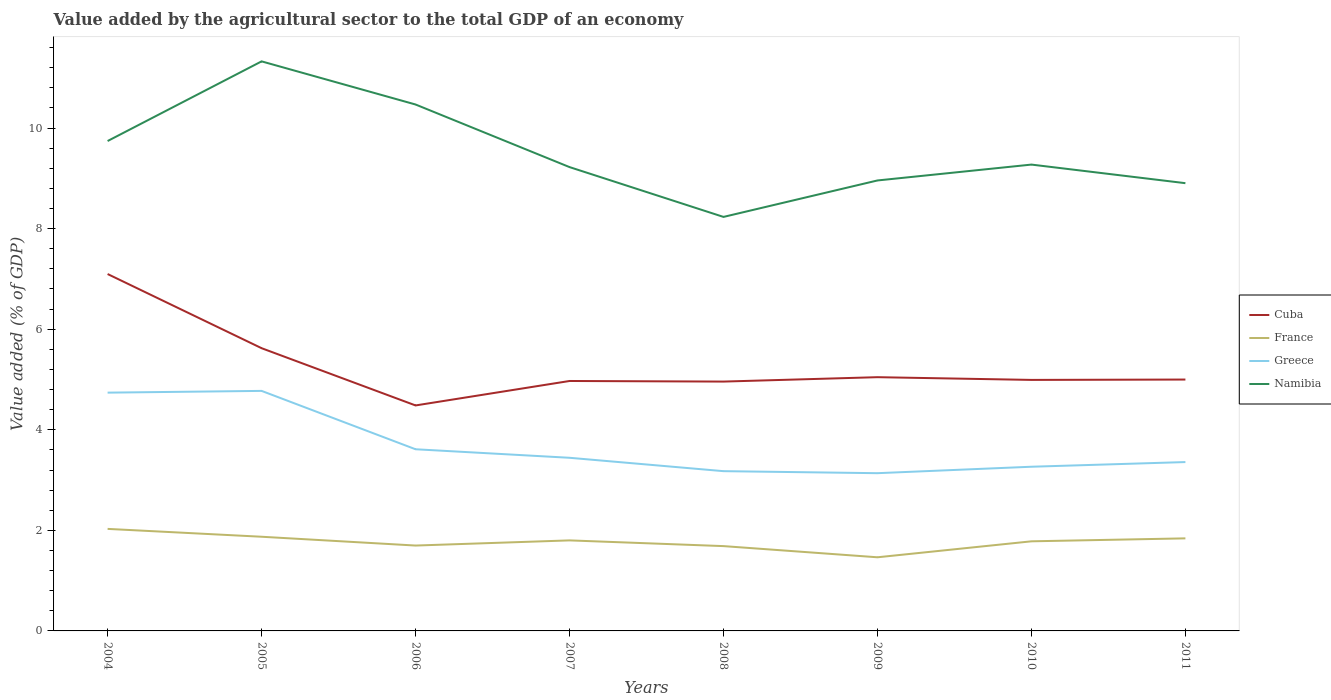How many different coloured lines are there?
Ensure brevity in your answer.  4. Does the line corresponding to France intersect with the line corresponding to Greece?
Your answer should be very brief. No. Across all years, what is the maximum value added by the agricultural sector to the total GDP in Cuba?
Ensure brevity in your answer.  4.48. In which year was the value added by the agricultural sector to the total GDP in Greece maximum?
Offer a terse response. 2009. What is the total value added by the agricultural sector to the total GDP in Greece in the graph?
Your answer should be very brief. 0.25. What is the difference between the highest and the second highest value added by the agricultural sector to the total GDP in Cuba?
Ensure brevity in your answer.  2.61. What is the difference between two consecutive major ticks on the Y-axis?
Provide a short and direct response. 2. Where does the legend appear in the graph?
Your answer should be compact. Center right. What is the title of the graph?
Offer a terse response. Value added by the agricultural sector to the total GDP of an economy. What is the label or title of the X-axis?
Make the answer very short. Years. What is the label or title of the Y-axis?
Ensure brevity in your answer.  Value added (% of GDP). What is the Value added (% of GDP) in Cuba in 2004?
Offer a terse response. 7.1. What is the Value added (% of GDP) in France in 2004?
Keep it short and to the point. 2.03. What is the Value added (% of GDP) in Greece in 2004?
Provide a short and direct response. 4.74. What is the Value added (% of GDP) in Namibia in 2004?
Offer a terse response. 9.74. What is the Value added (% of GDP) of Cuba in 2005?
Give a very brief answer. 5.62. What is the Value added (% of GDP) in France in 2005?
Your answer should be very brief. 1.87. What is the Value added (% of GDP) of Greece in 2005?
Offer a terse response. 4.77. What is the Value added (% of GDP) in Namibia in 2005?
Give a very brief answer. 11.33. What is the Value added (% of GDP) of Cuba in 2006?
Keep it short and to the point. 4.48. What is the Value added (% of GDP) in France in 2006?
Make the answer very short. 1.7. What is the Value added (% of GDP) in Greece in 2006?
Provide a succinct answer. 3.61. What is the Value added (% of GDP) in Namibia in 2006?
Offer a terse response. 10.47. What is the Value added (% of GDP) of Cuba in 2007?
Provide a short and direct response. 4.97. What is the Value added (% of GDP) of France in 2007?
Give a very brief answer. 1.8. What is the Value added (% of GDP) in Greece in 2007?
Your answer should be compact. 3.44. What is the Value added (% of GDP) in Namibia in 2007?
Provide a short and direct response. 9.22. What is the Value added (% of GDP) in Cuba in 2008?
Your answer should be compact. 4.96. What is the Value added (% of GDP) of France in 2008?
Provide a short and direct response. 1.69. What is the Value added (% of GDP) of Greece in 2008?
Your answer should be compact. 3.18. What is the Value added (% of GDP) in Namibia in 2008?
Provide a succinct answer. 8.23. What is the Value added (% of GDP) of Cuba in 2009?
Provide a short and direct response. 5.05. What is the Value added (% of GDP) in France in 2009?
Your response must be concise. 1.46. What is the Value added (% of GDP) of Greece in 2009?
Keep it short and to the point. 3.14. What is the Value added (% of GDP) in Namibia in 2009?
Make the answer very short. 8.96. What is the Value added (% of GDP) of Cuba in 2010?
Your answer should be very brief. 4.99. What is the Value added (% of GDP) in France in 2010?
Make the answer very short. 1.78. What is the Value added (% of GDP) in Greece in 2010?
Your answer should be very brief. 3.27. What is the Value added (% of GDP) in Namibia in 2010?
Keep it short and to the point. 9.27. What is the Value added (% of GDP) in Cuba in 2011?
Offer a terse response. 5. What is the Value added (% of GDP) of France in 2011?
Provide a short and direct response. 1.84. What is the Value added (% of GDP) in Greece in 2011?
Your response must be concise. 3.36. What is the Value added (% of GDP) in Namibia in 2011?
Offer a very short reply. 8.9. Across all years, what is the maximum Value added (% of GDP) of Cuba?
Provide a succinct answer. 7.1. Across all years, what is the maximum Value added (% of GDP) in France?
Ensure brevity in your answer.  2.03. Across all years, what is the maximum Value added (% of GDP) of Greece?
Offer a very short reply. 4.77. Across all years, what is the maximum Value added (% of GDP) in Namibia?
Provide a succinct answer. 11.33. Across all years, what is the minimum Value added (% of GDP) in Cuba?
Make the answer very short. 4.48. Across all years, what is the minimum Value added (% of GDP) in France?
Your answer should be very brief. 1.46. Across all years, what is the minimum Value added (% of GDP) of Greece?
Keep it short and to the point. 3.14. Across all years, what is the minimum Value added (% of GDP) of Namibia?
Keep it short and to the point. 8.23. What is the total Value added (% of GDP) of Cuba in the graph?
Offer a terse response. 42.17. What is the total Value added (% of GDP) of France in the graph?
Provide a short and direct response. 14.17. What is the total Value added (% of GDP) of Greece in the graph?
Your response must be concise. 29.51. What is the total Value added (% of GDP) in Namibia in the graph?
Your answer should be very brief. 76.13. What is the difference between the Value added (% of GDP) of Cuba in 2004 and that in 2005?
Offer a terse response. 1.47. What is the difference between the Value added (% of GDP) in France in 2004 and that in 2005?
Offer a very short reply. 0.16. What is the difference between the Value added (% of GDP) in Greece in 2004 and that in 2005?
Provide a succinct answer. -0.03. What is the difference between the Value added (% of GDP) of Namibia in 2004 and that in 2005?
Your answer should be very brief. -1.58. What is the difference between the Value added (% of GDP) in Cuba in 2004 and that in 2006?
Ensure brevity in your answer.  2.61. What is the difference between the Value added (% of GDP) in France in 2004 and that in 2006?
Your answer should be very brief. 0.33. What is the difference between the Value added (% of GDP) of Greece in 2004 and that in 2006?
Keep it short and to the point. 1.13. What is the difference between the Value added (% of GDP) in Namibia in 2004 and that in 2006?
Provide a short and direct response. -0.73. What is the difference between the Value added (% of GDP) in Cuba in 2004 and that in 2007?
Your response must be concise. 2.13. What is the difference between the Value added (% of GDP) in France in 2004 and that in 2007?
Provide a short and direct response. 0.23. What is the difference between the Value added (% of GDP) of Greece in 2004 and that in 2007?
Ensure brevity in your answer.  1.3. What is the difference between the Value added (% of GDP) of Namibia in 2004 and that in 2007?
Offer a terse response. 0.52. What is the difference between the Value added (% of GDP) in Cuba in 2004 and that in 2008?
Make the answer very short. 2.14. What is the difference between the Value added (% of GDP) in France in 2004 and that in 2008?
Ensure brevity in your answer.  0.34. What is the difference between the Value added (% of GDP) of Greece in 2004 and that in 2008?
Offer a very short reply. 1.56. What is the difference between the Value added (% of GDP) in Namibia in 2004 and that in 2008?
Keep it short and to the point. 1.51. What is the difference between the Value added (% of GDP) in Cuba in 2004 and that in 2009?
Offer a terse response. 2.05. What is the difference between the Value added (% of GDP) of France in 2004 and that in 2009?
Ensure brevity in your answer.  0.56. What is the difference between the Value added (% of GDP) in Greece in 2004 and that in 2009?
Your response must be concise. 1.6. What is the difference between the Value added (% of GDP) in Namibia in 2004 and that in 2009?
Provide a short and direct response. 0.78. What is the difference between the Value added (% of GDP) in Cuba in 2004 and that in 2010?
Provide a short and direct response. 2.11. What is the difference between the Value added (% of GDP) of France in 2004 and that in 2010?
Offer a very short reply. 0.25. What is the difference between the Value added (% of GDP) in Greece in 2004 and that in 2010?
Your answer should be compact. 1.47. What is the difference between the Value added (% of GDP) of Namibia in 2004 and that in 2010?
Your answer should be compact. 0.47. What is the difference between the Value added (% of GDP) in Cuba in 2004 and that in 2011?
Offer a very short reply. 2.1. What is the difference between the Value added (% of GDP) in France in 2004 and that in 2011?
Offer a terse response. 0.19. What is the difference between the Value added (% of GDP) of Greece in 2004 and that in 2011?
Your answer should be very brief. 1.38. What is the difference between the Value added (% of GDP) in Namibia in 2004 and that in 2011?
Give a very brief answer. 0.84. What is the difference between the Value added (% of GDP) in Cuba in 2005 and that in 2006?
Your response must be concise. 1.14. What is the difference between the Value added (% of GDP) of France in 2005 and that in 2006?
Keep it short and to the point. 0.17. What is the difference between the Value added (% of GDP) of Greece in 2005 and that in 2006?
Provide a short and direct response. 1.16. What is the difference between the Value added (% of GDP) of Namibia in 2005 and that in 2006?
Offer a terse response. 0.86. What is the difference between the Value added (% of GDP) in Cuba in 2005 and that in 2007?
Provide a succinct answer. 0.65. What is the difference between the Value added (% of GDP) in France in 2005 and that in 2007?
Your answer should be compact. 0.07. What is the difference between the Value added (% of GDP) in Greece in 2005 and that in 2007?
Ensure brevity in your answer.  1.33. What is the difference between the Value added (% of GDP) in Namibia in 2005 and that in 2007?
Ensure brevity in your answer.  2.1. What is the difference between the Value added (% of GDP) in Cuba in 2005 and that in 2008?
Make the answer very short. 0.66. What is the difference between the Value added (% of GDP) of France in 2005 and that in 2008?
Offer a terse response. 0.19. What is the difference between the Value added (% of GDP) of Greece in 2005 and that in 2008?
Ensure brevity in your answer.  1.6. What is the difference between the Value added (% of GDP) of Namibia in 2005 and that in 2008?
Provide a short and direct response. 3.09. What is the difference between the Value added (% of GDP) in Cuba in 2005 and that in 2009?
Provide a succinct answer. 0.58. What is the difference between the Value added (% of GDP) in France in 2005 and that in 2009?
Keep it short and to the point. 0.41. What is the difference between the Value added (% of GDP) of Greece in 2005 and that in 2009?
Your answer should be compact. 1.64. What is the difference between the Value added (% of GDP) in Namibia in 2005 and that in 2009?
Your answer should be compact. 2.37. What is the difference between the Value added (% of GDP) in Cuba in 2005 and that in 2010?
Provide a succinct answer. 0.63. What is the difference between the Value added (% of GDP) of France in 2005 and that in 2010?
Offer a terse response. 0.09. What is the difference between the Value added (% of GDP) of Greece in 2005 and that in 2010?
Provide a short and direct response. 1.51. What is the difference between the Value added (% of GDP) of Namibia in 2005 and that in 2010?
Keep it short and to the point. 2.05. What is the difference between the Value added (% of GDP) of Cuba in 2005 and that in 2011?
Offer a terse response. 0.62. What is the difference between the Value added (% of GDP) in France in 2005 and that in 2011?
Offer a terse response. 0.03. What is the difference between the Value added (% of GDP) in Greece in 2005 and that in 2011?
Make the answer very short. 1.42. What is the difference between the Value added (% of GDP) of Namibia in 2005 and that in 2011?
Offer a very short reply. 2.42. What is the difference between the Value added (% of GDP) of Cuba in 2006 and that in 2007?
Your answer should be compact. -0.49. What is the difference between the Value added (% of GDP) in France in 2006 and that in 2007?
Your answer should be compact. -0.1. What is the difference between the Value added (% of GDP) of Greece in 2006 and that in 2007?
Offer a very short reply. 0.17. What is the difference between the Value added (% of GDP) of Namibia in 2006 and that in 2007?
Provide a succinct answer. 1.24. What is the difference between the Value added (% of GDP) of Cuba in 2006 and that in 2008?
Provide a short and direct response. -0.47. What is the difference between the Value added (% of GDP) in France in 2006 and that in 2008?
Make the answer very short. 0.01. What is the difference between the Value added (% of GDP) of Greece in 2006 and that in 2008?
Keep it short and to the point. 0.44. What is the difference between the Value added (% of GDP) in Namibia in 2006 and that in 2008?
Offer a terse response. 2.24. What is the difference between the Value added (% of GDP) in Cuba in 2006 and that in 2009?
Keep it short and to the point. -0.56. What is the difference between the Value added (% of GDP) of France in 2006 and that in 2009?
Provide a short and direct response. 0.23. What is the difference between the Value added (% of GDP) of Greece in 2006 and that in 2009?
Offer a very short reply. 0.48. What is the difference between the Value added (% of GDP) in Namibia in 2006 and that in 2009?
Give a very brief answer. 1.51. What is the difference between the Value added (% of GDP) of Cuba in 2006 and that in 2010?
Give a very brief answer. -0.51. What is the difference between the Value added (% of GDP) in France in 2006 and that in 2010?
Keep it short and to the point. -0.08. What is the difference between the Value added (% of GDP) of Greece in 2006 and that in 2010?
Offer a very short reply. 0.35. What is the difference between the Value added (% of GDP) of Namibia in 2006 and that in 2010?
Your response must be concise. 1.19. What is the difference between the Value added (% of GDP) of Cuba in 2006 and that in 2011?
Your answer should be very brief. -0.51. What is the difference between the Value added (% of GDP) in France in 2006 and that in 2011?
Make the answer very short. -0.14. What is the difference between the Value added (% of GDP) of Greece in 2006 and that in 2011?
Provide a short and direct response. 0.25. What is the difference between the Value added (% of GDP) of Namibia in 2006 and that in 2011?
Give a very brief answer. 1.56. What is the difference between the Value added (% of GDP) in Cuba in 2007 and that in 2008?
Ensure brevity in your answer.  0.01. What is the difference between the Value added (% of GDP) of France in 2007 and that in 2008?
Make the answer very short. 0.11. What is the difference between the Value added (% of GDP) in Greece in 2007 and that in 2008?
Your response must be concise. 0.27. What is the difference between the Value added (% of GDP) of Cuba in 2007 and that in 2009?
Provide a succinct answer. -0.08. What is the difference between the Value added (% of GDP) in France in 2007 and that in 2009?
Your response must be concise. 0.34. What is the difference between the Value added (% of GDP) in Greece in 2007 and that in 2009?
Provide a succinct answer. 0.31. What is the difference between the Value added (% of GDP) in Namibia in 2007 and that in 2009?
Ensure brevity in your answer.  0.27. What is the difference between the Value added (% of GDP) in Cuba in 2007 and that in 2010?
Keep it short and to the point. -0.02. What is the difference between the Value added (% of GDP) in France in 2007 and that in 2010?
Offer a terse response. 0.02. What is the difference between the Value added (% of GDP) in Greece in 2007 and that in 2010?
Provide a succinct answer. 0.18. What is the difference between the Value added (% of GDP) of Namibia in 2007 and that in 2010?
Provide a succinct answer. -0.05. What is the difference between the Value added (% of GDP) of Cuba in 2007 and that in 2011?
Your answer should be very brief. -0.03. What is the difference between the Value added (% of GDP) in France in 2007 and that in 2011?
Ensure brevity in your answer.  -0.04. What is the difference between the Value added (% of GDP) in Greece in 2007 and that in 2011?
Your response must be concise. 0.09. What is the difference between the Value added (% of GDP) in Namibia in 2007 and that in 2011?
Provide a succinct answer. 0.32. What is the difference between the Value added (% of GDP) of Cuba in 2008 and that in 2009?
Your answer should be compact. -0.09. What is the difference between the Value added (% of GDP) in France in 2008 and that in 2009?
Provide a short and direct response. 0.22. What is the difference between the Value added (% of GDP) in Greece in 2008 and that in 2009?
Your answer should be compact. 0.04. What is the difference between the Value added (% of GDP) in Namibia in 2008 and that in 2009?
Offer a terse response. -0.72. What is the difference between the Value added (% of GDP) of Cuba in 2008 and that in 2010?
Give a very brief answer. -0.03. What is the difference between the Value added (% of GDP) in France in 2008 and that in 2010?
Your response must be concise. -0.1. What is the difference between the Value added (% of GDP) of Greece in 2008 and that in 2010?
Your answer should be compact. -0.09. What is the difference between the Value added (% of GDP) in Namibia in 2008 and that in 2010?
Your answer should be compact. -1.04. What is the difference between the Value added (% of GDP) of Cuba in 2008 and that in 2011?
Make the answer very short. -0.04. What is the difference between the Value added (% of GDP) of France in 2008 and that in 2011?
Your answer should be compact. -0.15. What is the difference between the Value added (% of GDP) in Greece in 2008 and that in 2011?
Your answer should be compact. -0.18. What is the difference between the Value added (% of GDP) of Namibia in 2008 and that in 2011?
Provide a succinct answer. -0.67. What is the difference between the Value added (% of GDP) in Cuba in 2009 and that in 2010?
Your answer should be compact. 0.05. What is the difference between the Value added (% of GDP) of France in 2009 and that in 2010?
Your answer should be compact. -0.32. What is the difference between the Value added (% of GDP) in Greece in 2009 and that in 2010?
Provide a succinct answer. -0.13. What is the difference between the Value added (% of GDP) in Namibia in 2009 and that in 2010?
Make the answer very short. -0.32. What is the difference between the Value added (% of GDP) of Cuba in 2009 and that in 2011?
Provide a short and direct response. 0.05. What is the difference between the Value added (% of GDP) of France in 2009 and that in 2011?
Make the answer very short. -0.38. What is the difference between the Value added (% of GDP) in Greece in 2009 and that in 2011?
Provide a short and direct response. -0.22. What is the difference between the Value added (% of GDP) in Namibia in 2009 and that in 2011?
Offer a terse response. 0.05. What is the difference between the Value added (% of GDP) in Cuba in 2010 and that in 2011?
Your answer should be compact. -0.01. What is the difference between the Value added (% of GDP) in France in 2010 and that in 2011?
Make the answer very short. -0.06. What is the difference between the Value added (% of GDP) in Greece in 2010 and that in 2011?
Your answer should be very brief. -0.09. What is the difference between the Value added (% of GDP) of Namibia in 2010 and that in 2011?
Offer a very short reply. 0.37. What is the difference between the Value added (% of GDP) in Cuba in 2004 and the Value added (% of GDP) in France in 2005?
Keep it short and to the point. 5.22. What is the difference between the Value added (% of GDP) of Cuba in 2004 and the Value added (% of GDP) of Greece in 2005?
Provide a short and direct response. 2.32. What is the difference between the Value added (% of GDP) in Cuba in 2004 and the Value added (% of GDP) in Namibia in 2005?
Ensure brevity in your answer.  -4.23. What is the difference between the Value added (% of GDP) of France in 2004 and the Value added (% of GDP) of Greece in 2005?
Offer a terse response. -2.74. What is the difference between the Value added (% of GDP) in France in 2004 and the Value added (% of GDP) in Namibia in 2005?
Provide a succinct answer. -9.3. What is the difference between the Value added (% of GDP) in Greece in 2004 and the Value added (% of GDP) in Namibia in 2005?
Your response must be concise. -6.59. What is the difference between the Value added (% of GDP) of Cuba in 2004 and the Value added (% of GDP) of France in 2006?
Offer a very short reply. 5.4. What is the difference between the Value added (% of GDP) in Cuba in 2004 and the Value added (% of GDP) in Greece in 2006?
Give a very brief answer. 3.48. What is the difference between the Value added (% of GDP) in Cuba in 2004 and the Value added (% of GDP) in Namibia in 2006?
Make the answer very short. -3.37. What is the difference between the Value added (% of GDP) of France in 2004 and the Value added (% of GDP) of Greece in 2006?
Offer a very short reply. -1.58. What is the difference between the Value added (% of GDP) of France in 2004 and the Value added (% of GDP) of Namibia in 2006?
Your answer should be compact. -8.44. What is the difference between the Value added (% of GDP) of Greece in 2004 and the Value added (% of GDP) of Namibia in 2006?
Your response must be concise. -5.73. What is the difference between the Value added (% of GDP) in Cuba in 2004 and the Value added (% of GDP) in France in 2007?
Your answer should be very brief. 5.3. What is the difference between the Value added (% of GDP) in Cuba in 2004 and the Value added (% of GDP) in Greece in 2007?
Your response must be concise. 3.65. What is the difference between the Value added (% of GDP) of Cuba in 2004 and the Value added (% of GDP) of Namibia in 2007?
Provide a succinct answer. -2.13. What is the difference between the Value added (% of GDP) in France in 2004 and the Value added (% of GDP) in Greece in 2007?
Keep it short and to the point. -1.41. What is the difference between the Value added (% of GDP) of France in 2004 and the Value added (% of GDP) of Namibia in 2007?
Provide a short and direct response. -7.2. What is the difference between the Value added (% of GDP) of Greece in 2004 and the Value added (% of GDP) of Namibia in 2007?
Keep it short and to the point. -4.49. What is the difference between the Value added (% of GDP) in Cuba in 2004 and the Value added (% of GDP) in France in 2008?
Offer a terse response. 5.41. What is the difference between the Value added (% of GDP) in Cuba in 2004 and the Value added (% of GDP) in Greece in 2008?
Provide a short and direct response. 3.92. What is the difference between the Value added (% of GDP) in Cuba in 2004 and the Value added (% of GDP) in Namibia in 2008?
Your answer should be compact. -1.14. What is the difference between the Value added (% of GDP) of France in 2004 and the Value added (% of GDP) of Greece in 2008?
Offer a terse response. -1.15. What is the difference between the Value added (% of GDP) of France in 2004 and the Value added (% of GDP) of Namibia in 2008?
Ensure brevity in your answer.  -6.2. What is the difference between the Value added (% of GDP) of Greece in 2004 and the Value added (% of GDP) of Namibia in 2008?
Your answer should be very brief. -3.49. What is the difference between the Value added (% of GDP) in Cuba in 2004 and the Value added (% of GDP) in France in 2009?
Make the answer very short. 5.63. What is the difference between the Value added (% of GDP) in Cuba in 2004 and the Value added (% of GDP) in Greece in 2009?
Ensure brevity in your answer.  3.96. What is the difference between the Value added (% of GDP) of Cuba in 2004 and the Value added (% of GDP) of Namibia in 2009?
Provide a short and direct response. -1.86. What is the difference between the Value added (% of GDP) in France in 2004 and the Value added (% of GDP) in Greece in 2009?
Give a very brief answer. -1.11. What is the difference between the Value added (% of GDP) in France in 2004 and the Value added (% of GDP) in Namibia in 2009?
Provide a short and direct response. -6.93. What is the difference between the Value added (% of GDP) in Greece in 2004 and the Value added (% of GDP) in Namibia in 2009?
Provide a succinct answer. -4.22. What is the difference between the Value added (% of GDP) in Cuba in 2004 and the Value added (% of GDP) in France in 2010?
Your answer should be compact. 5.32. What is the difference between the Value added (% of GDP) of Cuba in 2004 and the Value added (% of GDP) of Greece in 2010?
Keep it short and to the point. 3.83. What is the difference between the Value added (% of GDP) in Cuba in 2004 and the Value added (% of GDP) in Namibia in 2010?
Provide a succinct answer. -2.18. What is the difference between the Value added (% of GDP) of France in 2004 and the Value added (% of GDP) of Greece in 2010?
Provide a succinct answer. -1.24. What is the difference between the Value added (% of GDP) in France in 2004 and the Value added (% of GDP) in Namibia in 2010?
Your response must be concise. -7.25. What is the difference between the Value added (% of GDP) of Greece in 2004 and the Value added (% of GDP) of Namibia in 2010?
Provide a short and direct response. -4.54. What is the difference between the Value added (% of GDP) of Cuba in 2004 and the Value added (% of GDP) of France in 2011?
Keep it short and to the point. 5.26. What is the difference between the Value added (% of GDP) of Cuba in 2004 and the Value added (% of GDP) of Greece in 2011?
Your response must be concise. 3.74. What is the difference between the Value added (% of GDP) in Cuba in 2004 and the Value added (% of GDP) in Namibia in 2011?
Give a very brief answer. -1.81. What is the difference between the Value added (% of GDP) in France in 2004 and the Value added (% of GDP) in Greece in 2011?
Make the answer very short. -1.33. What is the difference between the Value added (% of GDP) in France in 2004 and the Value added (% of GDP) in Namibia in 2011?
Give a very brief answer. -6.88. What is the difference between the Value added (% of GDP) of Greece in 2004 and the Value added (% of GDP) of Namibia in 2011?
Offer a terse response. -4.17. What is the difference between the Value added (% of GDP) in Cuba in 2005 and the Value added (% of GDP) in France in 2006?
Your response must be concise. 3.92. What is the difference between the Value added (% of GDP) in Cuba in 2005 and the Value added (% of GDP) in Greece in 2006?
Make the answer very short. 2.01. What is the difference between the Value added (% of GDP) in Cuba in 2005 and the Value added (% of GDP) in Namibia in 2006?
Provide a short and direct response. -4.85. What is the difference between the Value added (% of GDP) in France in 2005 and the Value added (% of GDP) in Greece in 2006?
Keep it short and to the point. -1.74. What is the difference between the Value added (% of GDP) of France in 2005 and the Value added (% of GDP) of Namibia in 2006?
Provide a short and direct response. -8.6. What is the difference between the Value added (% of GDP) of Greece in 2005 and the Value added (% of GDP) of Namibia in 2006?
Provide a succinct answer. -5.7. What is the difference between the Value added (% of GDP) in Cuba in 2005 and the Value added (% of GDP) in France in 2007?
Offer a very short reply. 3.82. What is the difference between the Value added (% of GDP) of Cuba in 2005 and the Value added (% of GDP) of Greece in 2007?
Your answer should be compact. 2.18. What is the difference between the Value added (% of GDP) in Cuba in 2005 and the Value added (% of GDP) in Namibia in 2007?
Make the answer very short. -3.6. What is the difference between the Value added (% of GDP) of France in 2005 and the Value added (% of GDP) of Greece in 2007?
Provide a short and direct response. -1.57. What is the difference between the Value added (% of GDP) in France in 2005 and the Value added (% of GDP) in Namibia in 2007?
Make the answer very short. -7.35. What is the difference between the Value added (% of GDP) of Greece in 2005 and the Value added (% of GDP) of Namibia in 2007?
Provide a succinct answer. -4.45. What is the difference between the Value added (% of GDP) in Cuba in 2005 and the Value added (% of GDP) in France in 2008?
Offer a very short reply. 3.94. What is the difference between the Value added (% of GDP) in Cuba in 2005 and the Value added (% of GDP) in Greece in 2008?
Your response must be concise. 2.45. What is the difference between the Value added (% of GDP) of Cuba in 2005 and the Value added (% of GDP) of Namibia in 2008?
Ensure brevity in your answer.  -2.61. What is the difference between the Value added (% of GDP) of France in 2005 and the Value added (% of GDP) of Greece in 2008?
Your answer should be very brief. -1.3. What is the difference between the Value added (% of GDP) in France in 2005 and the Value added (% of GDP) in Namibia in 2008?
Ensure brevity in your answer.  -6.36. What is the difference between the Value added (% of GDP) of Greece in 2005 and the Value added (% of GDP) of Namibia in 2008?
Make the answer very short. -3.46. What is the difference between the Value added (% of GDP) of Cuba in 2005 and the Value added (% of GDP) of France in 2009?
Offer a terse response. 4.16. What is the difference between the Value added (% of GDP) in Cuba in 2005 and the Value added (% of GDP) in Greece in 2009?
Your answer should be very brief. 2.49. What is the difference between the Value added (% of GDP) of Cuba in 2005 and the Value added (% of GDP) of Namibia in 2009?
Your answer should be very brief. -3.34. What is the difference between the Value added (% of GDP) in France in 2005 and the Value added (% of GDP) in Greece in 2009?
Offer a very short reply. -1.26. What is the difference between the Value added (% of GDP) of France in 2005 and the Value added (% of GDP) of Namibia in 2009?
Give a very brief answer. -7.09. What is the difference between the Value added (% of GDP) in Greece in 2005 and the Value added (% of GDP) in Namibia in 2009?
Provide a short and direct response. -4.18. What is the difference between the Value added (% of GDP) in Cuba in 2005 and the Value added (% of GDP) in France in 2010?
Offer a very short reply. 3.84. What is the difference between the Value added (% of GDP) of Cuba in 2005 and the Value added (% of GDP) of Greece in 2010?
Your answer should be compact. 2.36. What is the difference between the Value added (% of GDP) in Cuba in 2005 and the Value added (% of GDP) in Namibia in 2010?
Make the answer very short. -3.65. What is the difference between the Value added (% of GDP) of France in 2005 and the Value added (% of GDP) of Greece in 2010?
Offer a very short reply. -1.39. What is the difference between the Value added (% of GDP) in France in 2005 and the Value added (% of GDP) in Namibia in 2010?
Your response must be concise. -7.4. What is the difference between the Value added (% of GDP) of Greece in 2005 and the Value added (% of GDP) of Namibia in 2010?
Give a very brief answer. -4.5. What is the difference between the Value added (% of GDP) of Cuba in 2005 and the Value added (% of GDP) of France in 2011?
Offer a very short reply. 3.78. What is the difference between the Value added (% of GDP) in Cuba in 2005 and the Value added (% of GDP) in Greece in 2011?
Your answer should be very brief. 2.26. What is the difference between the Value added (% of GDP) of Cuba in 2005 and the Value added (% of GDP) of Namibia in 2011?
Make the answer very short. -3.28. What is the difference between the Value added (% of GDP) in France in 2005 and the Value added (% of GDP) in Greece in 2011?
Provide a succinct answer. -1.49. What is the difference between the Value added (% of GDP) of France in 2005 and the Value added (% of GDP) of Namibia in 2011?
Give a very brief answer. -7.03. What is the difference between the Value added (% of GDP) in Greece in 2005 and the Value added (% of GDP) in Namibia in 2011?
Ensure brevity in your answer.  -4.13. What is the difference between the Value added (% of GDP) of Cuba in 2006 and the Value added (% of GDP) of France in 2007?
Keep it short and to the point. 2.68. What is the difference between the Value added (% of GDP) of Cuba in 2006 and the Value added (% of GDP) of Greece in 2007?
Ensure brevity in your answer.  1.04. What is the difference between the Value added (% of GDP) of Cuba in 2006 and the Value added (% of GDP) of Namibia in 2007?
Keep it short and to the point. -4.74. What is the difference between the Value added (% of GDP) of France in 2006 and the Value added (% of GDP) of Greece in 2007?
Offer a very short reply. -1.75. What is the difference between the Value added (% of GDP) of France in 2006 and the Value added (% of GDP) of Namibia in 2007?
Make the answer very short. -7.53. What is the difference between the Value added (% of GDP) of Greece in 2006 and the Value added (% of GDP) of Namibia in 2007?
Provide a succinct answer. -5.61. What is the difference between the Value added (% of GDP) of Cuba in 2006 and the Value added (% of GDP) of France in 2008?
Provide a short and direct response. 2.8. What is the difference between the Value added (% of GDP) in Cuba in 2006 and the Value added (% of GDP) in Greece in 2008?
Offer a very short reply. 1.31. What is the difference between the Value added (% of GDP) of Cuba in 2006 and the Value added (% of GDP) of Namibia in 2008?
Your answer should be very brief. -3.75. What is the difference between the Value added (% of GDP) of France in 2006 and the Value added (% of GDP) of Greece in 2008?
Your answer should be compact. -1.48. What is the difference between the Value added (% of GDP) of France in 2006 and the Value added (% of GDP) of Namibia in 2008?
Keep it short and to the point. -6.54. What is the difference between the Value added (% of GDP) of Greece in 2006 and the Value added (% of GDP) of Namibia in 2008?
Ensure brevity in your answer.  -4.62. What is the difference between the Value added (% of GDP) of Cuba in 2006 and the Value added (% of GDP) of France in 2009?
Ensure brevity in your answer.  3.02. What is the difference between the Value added (% of GDP) of Cuba in 2006 and the Value added (% of GDP) of Greece in 2009?
Your response must be concise. 1.35. What is the difference between the Value added (% of GDP) of Cuba in 2006 and the Value added (% of GDP) of Namibia in 2009?
Provide a short and direct response. -4.47. What is the difference between the Value added (% of GDP) of France in 2006 and the Value added (% of GDP) of Greece in 2009?
Provide a succinct answer. -1.44. What is the difference between the Value added (% of GDP) of France in 2006 and the Value added (% of GDP) of Namibia in 2009?
Offer a very short reply. -7.26. What is the difference between the Value added (% of GDP) in Greece in 2006 and the Value added (% of GDP) in Namibia in 2009?
Offer a terse response. -5.35. What is the difference between the Value added (% of GDP) of Cuba in 2006 and the Value added (% of GDP) of France in 2010?
Give a very brief answer. 2.7. What is the difference between the Value added (% of GDP) of Cuba in 2006 and the Value added (% of GDP) of Greece in 2010?
Offer a terse response. 1.22. What is the difference between the Value added (% of GDP) of Cuba in 2006 and the Value added (% of GDP) of Namibia in 2010?
Offer a terse response. -4.79. What is the difference between the Value added (% of GDP) of France in 2006 and the Value added (% of GDP) of Greece in 2010?
Provide a short and direct response. -1.57. What is the difference between the Value added (% of GDP) of France in 2006 and the Value added (% of GDP) of Namibia in 2010?
Your response must be concise. -7.58. What is the difference between the Value added (% of GDP) in Greece in 2006 and the Value added (% of GDP) in Namibia in 2010?
Offer a terse response. -5.66. What is the difference between the Value added (% of GDP) in Cuba in 2006 and the Value added (% of GDP) in France in 2011?
Provide a short and direct response. 2.64. What is the difference between the Value added (% of GDP) of Cuba in 2006 and the Value added (% of GDP) of Greece in 2011?
Your answer should be compact. 1.13. What is the difference between the Value added (% of GDP) in Cuba in 2006 and the Value added (% of GDP) in Namibia in 2011?
Ensure brevity in your answer.  -4.42. What is the difference between the Value added (% of GDP) of France in 2006 and the Value added (% of GDP) of Greece in 2011?
Your answer should be compact. -1.66. What is the difference between the Value added (% of GDP) of France in 2006 and the Value added (% of GDP) of Namibia in 2011?
Your answer should be compact. -7.21. What is the difference between the Value added (% of GDP) in Greece in 2006 and the Value added (% of GDP) in Namibia in 2011?
Provide a succinct answer. -5.29. What is the difference between the Value added (% of GDP) in Cuba in 2007 and the Value added (% of GDP) in France in 2008?
Your answer should be compact. 3.28. What is the difference between the Value added (% of GDP) of Cuba in 2007 and the Value added (% of GDP) of Greece in 2008?
Ensure brevity in your answer.  1.79. What is the difference between the Value added (% of GDP) of Cuba in 2007 and the Value added (% of GDP) of Namibia in 2008?
Give a very brief answer. -3.26. What is the difference between the Value added (% of GDP) of France in 2007 and the Value added (% of GDP) of Greece in 2008?
Ensure brevity in your answer.  -1.38. What is the difference between the Value added (% of GDP) of France in 2007 and the Value added (% of GDP) of Namibia in 2008?
Ensure brevity in your answer.  -6.43. What is the difference between the Value added (% of GDP) in Greece in 2007 and the Value added (% of GDP) in Namibia in 2008?
Your answer should be compact. -4.79. What is the difference between the Value added (% of GDP) in Cuba in 2007 and the Value added (% of GDP) in France in 2009?
Offer a terse response. 3.51. What is the difference between the Value added (% of GDP) of Cuba in 2007 and the Value added (% of GDP) of Greece in 2009?
Your answer should be compact. 1.83. What is the difference between the Value added (% of GDP) in Cuba in 2007 and the Value added (% of GDP) in Namibia in 2009?
Provide a succinct answer. -3.99. What is the difference between the Value added (% of GDP) in France in 2007 and the Value added (% of GDP) in Greece in 2009?
Keep it short and to the point. -1.34. What is the difference between the Value added (% of GDP) of France in 2007 and the Value added (% of GDP) of Namibia in 2009?
Provide a short and direct response. -7.16. What is the difference between the Value added (% of GDP) in Greece in 2007 and the Value added (% of GDP) in Namibia in 2009?
Offer a very short reply. -5.52. What is the difference between the Value added (% of GDP) in Cuba in 2007 and the Value added (% of GDP) in France in 2010?
Keep it short and to the point. 3.19. What is the difference between the Value added (% of GDP) in Cuba in 2007 and the Value added (% of GDP) in Greece in 2010?
Your answer should be very brief. 1.71. What is the difference between the Value added (% of GDP) in Cuba in 2007 and the Value added (% of GDP) in Namibia in 2010?
Keep it short and to the point. -4.3. What is the difference between the Value added (% of GDP) of France in 2007 and the Value added (% of GDP) of Greece in 2010?
Ensure brevity in your answer.  -1.46. What is the difference between the Value added (% of GDP) of France in 2007 and the Value added (% of GDP) of Namibia in 2010?
Your answer should be compact. -7.47. What is the difference between the Value added (% of GDP) in Greece in 2007 and the Value added (% of GDP) in Namibia in 2010?
Ensure brevity in your answer.  -5.83. What is the difference between the Value added (% of GDP) of Cuba in 2007 and the Value added (% of GDP) of France in 2011?
Make the answer very short. 3.13. What is the difference between the Value added (% of GDP) in Cuba in 2007 and the Value added (% of GDP) in Greece in 2011?
Your answer should be very brief. 1.61. What is the difference between the Value added (% of GDP) of Cuba in 2007 and the Value added (% of GDP) of Namibia in 2011?
Ensure brevity in your answer.  -3.93. What is the difference between the Value added (% of GDP) of France in 2007 and the Value added (% of GDP) of Greece in 2011?
Offer a very short reply. -1.56. What is the difference between the Value added (% of GDP) of France in 2007 and the Value added (% of GDP) of Namibia in 2011?
Your answer should be very brief. -7.1. What is the difference between the Value added (% of GDP) of Greece in 2007 and the Value added (% of GDP) of Namibia in 2011?
Ensure brevity in your answer.  -5.46. What is the difference between the Value added (% of GDP) in Cuba in 2008 and the Value added (% of GDP) in France in 2009?
Provide a succinct answer. 3.49. What is the difference between the Value added (% of GDP) in Cuba in 2008 and the Value added (% of GDP) in Greece in 2009?
Provide a short and direct response. 1.82. What is the difference between the Value added (% of GDP) of Cuba in 2008 and the Value added (% of GDP) of Namibia in 2009?
Provide a short and direct response. -4. What is the difference between the Value added (% of GDP) of France in 2008 and the Value added (% of GDP) of Greece in 2009?
Give a very brief answer. -1.45. What is the difference between the Value added (% of GDP) of France in 2008 and the Value added (% of GDP) of Namibia in 2009?
Give a very brief answer. -7.27. What is the difference between the Value added (% of GDP) in Greece in 2008 and the Value added (% of GDP) in Namibia in 2009?
Offer a very short reply. -5.78. What is the difference between the Value added (% of GDP) of Cuba in 2008 and the Value added (% of GDP) of France in 2010?
Your answer should be very brief. 3.18. What is the difference between the Value added (% of GDP) in Cuba in 2008 and the Value added (% of GDP) in Greece in 2010?
Your answer should be very brief. 1.69. What is the difference between the Value added (% of GDP) in Cuba in 2008 and the Value added (% of GDP) in Namibia in 2010?
Your response must be concise. -4.32. What is the difference between the Value added (% of GDP) of France in 2008 and the Value added (% of GDP) of Greece in 2010?
Ensure brevity in your answer.  -1.58. What is the difference between the Value added (% of GDP) of France in 2008 and the Value added (% of GDP) of Namibia in 2010?
Your response must be concise. -7.59. What is the difference between the Value added (% of GDP) in Greece in 2008 and the Value added (% of GDP) in Namibia in 2010?
Ensure brevity in your answer.  -6.1. What is the difference between the Value added (% of GDP) in Cuba in 2008 and the Value added (% of GDP) in France in 2011?
Ensure brevity in your answer.  3.12. What is the difference between the Value added (% of GDP) of Cuba in 2008 and the Value added (% of GDP) of Greece in 2011?
Ensure brevity in your answer.  1.6. What is the difference between the Value added (% of GDP) in Cuba in 2008 and the Value added (% of GDP) in Namibia in 2011?
Keep it short and to the point. -3.95. What is the difference between the Value added (% of GDP) in France in 2008 and the Value added (% of GDP) in Greece in 2011?
Give a very brief answer. -1.67. What is the difference between the Value added (% of GDP) in France in 2008 and the Value added (% of GDP) in Namibia in 2011?
Keep it short and to the point. -7.22. What is the difference between the Value added (% of GDP) of Greece in 2008 and the Value added (% of GDP) of Namibia in 2011?
Your answer should be very brief. -5.73. What is the difference between the Value added (% of GDP) in Cuba in 2009 and the Value added (% of GDP) in France in 2010?
Make the answer very short. 3.26. What is the difference between the Value added (% of GDP) in Cuba in 2009 and the Value added (% of GDP) in Greece in 2010?
Provide a succinct answer. 1.78. What is the difference between the Value added (% of GDP) in Cuba in 2009 and the Value added (% of GDP) in Namibia in 2010?
Keep it short and to the point. -4.23. What is the difference between the Value added (% of GDP) in France in 2009 and the Value added (% of GDP) in Greece in 2010?
Make the answer very short. -1.8. What is the difference between the Value added (% of GDP) in France in 2009 and the Value added (% of GDP) in Namibia in 2010?
Offer a terse response. -7.81. What is the difference between the Value added (% of GDP) in Greece in 2009 and the Value added (% of GDP) in Namibia in 2010?
Ensure brevity in your answer.  -6.14. What is the difference between the Value added (% of GDP) in Cuba in 2009 and the Value added (% of GDP) in France in 2011?
Provide a short and direct response. 3.21. What is the difference between the Value added (% of GDP) of Cuba in 2009 and the Value added (% of GDP) of Greece in 2011?
Keep it short and to the point. 1.69. What is the difference between the Value added (% of GDP) in Cuba in 2009 and the Value added (% of GDP) in Namibia in 2011?
Your response must be concise. -3.86. What is the difference between the Value added (% of GDP) of France in 2009 and the Value added (% of GDP) of Greece in 2011?
Ensure brevity in your answer.  -1.89. What is the difference between the Value added (% of GDP) of France in 2009 and the Value added (% of GDP) of Namibia in 2011?
Your response must be concise. -7.44. What is the difference between the Value added (% of GDP) in Greece in 2009 and the Value added (% of GDP) in Namibia in 2011?
Provide a succinct answer. -5.77. What is the difference between the Value added (% of GDP) in Cuba in 2010 and the Value added (% of GDP) in France in 2011?
Your answer should be very brief. 3.15. What is the difference between the Value added (% of GDP) in Cuba in 2010 and the Value added (% of GDP) in Greece in 2011?
Provide a short and direct response. 1.63. What is the difference between the Value added (% of GDP) in Cuba in 2010 and the Value added (% of GDP) in Namibia in 2011?
Your answer should be compact. -3.91. What is the difference between the Value added (% of GDP) of France in 2010 and the Value added (% of GDP) of Greece in 2011?
Keep it short and to the point. -1.58. What is the difference between the Value added (% of GDP) of France in 2010 and the Value added (% of GDP) of Namibia in 2011?
Make the answer very short. -7.12. What is the difference between the Value added (% of GDP) in Greece in 2010 and the Value added (% of GDP) in Namibia in 2011?
Ensure brevity in your answer.  -5.64. What is the average Value added (% of GDP) in Cuba per year?
Ensure brevity in your answer.  5.27. What is the average Value added (% of GDP) of France per year?
Offer a terse response. 1.77. What is the average Value added (% of GDP) in Greece per year?
Provide a succinct answer. 3.69. What is the average Value added (% of GDP) of Namibia per year?
Your answer should be compact. 9.52. In the year 2004, what is the difference between the Value added (% of GDP) of Cuba and Value added (% of GDP) of France?
Offer a terse response. 5.07. In the year 2004, what is the difference between the Value added (% of GDP) of Cuba and Value added (% of GDP) of Greece?
Give a very brief answer. 2.36. In the year 2004, what is the difference between the Value added (% of GDP) in Cuba and Value added (% of GDP) in Namibia?
Offer a terse response. -2.64. In the year 2004, what is the difference between the Value added (% of GDP) of France and Value added (% of GDP) of Greece?
Your response must be concise. -2.71. In the year 2004, what is the difference between the Value added (% of GDP) in France and Value added (% of GDP) in Namibia?
Your answer should be very brief. -7.71. In the year 2004, what is the difference between the Value added (% of GDP) of Greece and Value added (% of GDP) of Namibia?
Keep it short and to the point. -5. In the year 2005, what is the difference between the Value added (% of GDP) of Cuba and Value added (% of GDP) of France?
Keep it short and to the point. 3.75. In the year 2005, what is the difference between the Value added (% of GDP) in Cuba and Value added (% of GDP) in Greece?
Your answer should be compact. 0.85. In the year 2005, what is the difference between the Value added (% of GDP) of Cuba and Value added (% of GDP) of Namibia?
Your answer should be very brief. -5.7. In the year 2005, what is the difference between the Value added (% of GDP) in France and Value added (% of GDP) in Greece?
Offer a terse response. -2.9. In the year 2005, what is the difference between the Value added (% of GDP) of France and Value added (% of GDP) of Namibia?
Your answer should be compact. -9.45. In the year 2005, what is the difference between the Value added (% of GDP) in Greece and Value added (% of GDP) in Namibia?
Your response must be concise. -6.55. In the year 2006, what is the difference between the Value added (% of GDP) of Cuba and Value added (% of GDP) of France?
Keep it short and to the point. 2.79. In the year 2006, what is the difference between the Value added (% of GDP) of Cuba and Value added (% of GDP) of Greece?
Your answer should be compact. 0.87. In the year 2006, what is the difference between the Value added (% of GDP) in Cuba and Value added (% of GDP) in Namibia?
Provide a succinct answer. -5.98. In the year 2006, what is the difference between the Value added (% of GDP) of France and Value added (% of GDP) of Greece?
Provide a succinct answer. -1.91. In the year 2006, what is the difference between the Value added (% of GDP) of France and Value added (% of GDP) of Namibia?
Offer a very short reply. -8.77. In the year 2006, what is the difference between the Value added (% of GDP) in Greece and Value added (% of GDP) in Namibia?
Ensure brevity in your answer.  -6.86. In the year 2007, what is the difference between the Value added (% of GDP) of Cuba and Value added (% of GDP) of France?
Your answer should be compact. 3.17. In the year 2007, what is the difference between the Value added (% of GDP) in Cuba and Value added (% of GDP) in Greece?
Ensure brevity in your answer.  1.53. In the year 2007, what is the difference between the Value added (% of GDP) in Cuba and Value added (% of GDP) in Namibia?
Ensure brevity in your answer.  -4.25. In the year 2007, what is the difference between the Value added (% of GDP) in France and Value added (% of GDP) in Greece?
Your response must be concise. -1.64. In the year 2007, what is the difference between the Value added (% of GDP) in France and Value added (% of GDP) in Namibia?
Provide a succinct answer. -7.42. In the year 2007, what is the difference between the Value added (% of GDP) of Greece and Value added (% of GDP) of Namibia?
Your answer should be compact. -5.78. In the year 2008, what is the difference between the Value added (% of GDP) of Cuba and Value added (% of GDP) of France?
Your response must be concise. 3.27. In the year 2008, what is the difference between the Value added (% of GDP) in Cuba and Value added (% of GDP) in Greece?
Offer a very short reply. 1.78. In the year 2008, what is the difference between the Value added (% of GDP) in Cuba and Value added (% of GDP) in Namibia?
Make the answer very short. -3.27. In the year 2008, what is the difference between the Value added (% of GDP) in France and Value added (% of GDP) in Greece?
Ensure brevity in your answer.  -1.49. In the year 2008, what is the difference between the Value added (% of GDP) of France and Value added (% of GDP) of Namibia?
Your answer should be compact. -6.55. In the year 2008, what is the difference between the Value added (% of GDP) of Greece and Value added (% of GDP) of Namibia?
Your response must be concise. -5.06. In the year 2009, what is the difference between the Value added (% of GDP) in Cuba and Value added (% of GDP) in France?
Provide a short and direct response. 3.58. In the year 2009, what is the difference between the Value added (% of GDP) in Cuba and Value added (% of GDP) in Greece?
Ensure brevity in your answer.  1.91. In the year 2009, what is the difference between the Value added (% of GDP) in Cuba and Value added (% of GDP) in Namibia?
Your answer should be very brief. -3.91. In the year 2009, what is the difference between the Value added (% of GDP) in France and Value added (% of GDP) in Greece?
Make the answer very short. -1.67. In the year 2009, what is the difference between the Value added (% of GDP) of France and Value added (% of GDP) of Namibia?
Your response must be concise. -7.49. In the year 2009, what is the difference between the Value added (% of GDP) of Greece and Value added (% of GDP) of Namibia?
Provide a succinct answer. -5.82. In the year 2010, what is the difference between the Value added (% of GDP) of Cuba and Value added (% of GDP) of France?
Your answer should be compact. 3.21. In the year 2010, what is the difference between the Value added (% of GDP) of Cuba and Value added (% of GDP) of Greece?
Provide a succinct answer. 1.73. In the year 2010, what is the difference between the Value added (% of GDP) of Cuba and Value added (% of GDP) of Namibia?
Keep it short and to the point. -4.28. In the year 2010, what is the difference between the Value added (% of GDP) in France and Value added (% of GDP) in Greece?
Keep it short and to the point. -1.48. In the year 2010, what is the difference between the Value added (% of GDP) in France and Value added (% of GDP) in Namibia?
Provide a short and direct response. -7.49. In the year 2010, what is the difference between the Value added (% of GDP) in Greece and Value added (% of GDP) in Namibia?
Ensure brevity in your answer.  -6.01. In the year 2011, what is the difference between the Value added (% of GDP) of Cuba and Value added (% of GDP) of France?
Make the answer very short. 3.16. In the year 2011, what is the difference between the Value added (% of GDP) of Cuba and Value added (% of GDP) of Greece?
Your answer should be very brief. 1.64. In the year 2011, what is the difference between the Value added (% of GDP) of Cuba and Value added (% of GDP) of Namibia?
Give a very brief answer. -3.91. In the year 2011, what is the difference between the Value added (% of GDP) in France and Value added (% of GDP) in Greece?
Your response must be concise. -1.52. In the year 2011, what is the difference between the Value added (% of GDP) of France and Value added (% of GDP) of Namibia?
Your response must be concise. -7.06. In the year 2011, what is the difference between the Value added (% of GDP) of Greece and Value added (% of GDP) of Namibia?
Your answer should be very brief. -5.55. What is the ratio of the Value added (% of GDP) of Cuba in 2004 to that in 2005?
Give a very brief answer. 1.26. What is the ratio of the Value added (% of GDP) of France in 2004 to that in 2005?
Provide a short and direct response. 1.08. What is the ratio of the Value added (% of GDP) of Namibia in 2004 to that in 2005?
Your response must be concise. 0.86. What is the ratio of the Value added (% of GDP) in Cuba in 2004 to that in 2006?
Give a very brief answer. 1.58. What is the ratio of the Value added (% of GDP) of France in 2004 to that in 2006?
Offer a terse response. 1.2. What is the ratio of the Value added (% of GDP) of Greece in 2004 to that in 2006?
Your answer should be very brief. 1.31. What is the ratio of the Value added (% of GDP) in Namibia in 2004 to that in 2006?
Your answer should be compact. 0.93. What is the ratio of the Value added (% of GDP) of Cuba in 2004 to that in 2007?
Your answer should be compact. 1.43. What is the ratio of the Value added (% of GDP) of France in 2004 to that in 2007?
Offer a very short reply. 1.13. What is the ratio of the Value added (% of GDP) of Greece in 2004 to that in 2007?
Provide a succinct answer. 1.38. What is the ratio of the Value added (% of GDP) of Namibia in 2004 to that in 2007?
Keep it short and to the point. 1.06. What is the ratio of the Value added (% of GDP) of Cuba in 2004 to that in 2008?
Provide a short and direct response. 1.43. What is the ratio of the Value added (% of GDP) in France in 2004 to that in 2008?
Offer a very short reply. 1.2. What is the ratio of the Value added (% of GDP) in Greece in 2004 to that in 2008?
Keep it short and to the point. 1.49. What is the ratio of the Value added (% of GDP) of Namibia in 2004 to that in 2008?
Your answer should be compact. 1.18. What is the ratio of the Value added (% of GDP) in Cuba in 2004 to that in 2009?
Offer a very short reply. 1.41. What is the ratio of the Value added (% of GDP) of France in 2004 to that in 2009?
Offer a very short reply. 1.39. What is the ratio of the Value added (% of GDP) in Greece in 2004 to that in 2009?
Keep it short and to the point. 1.51. What is the ratio of the Value added (% of GDP) of Namibia in 2004 to that in 2009?
Ensure brevity in your answer.  1.09. What is the ratio of the Value added (% of GDP) of Cuba in 2004 to that in 2010?
Your answer should be very brief. 1.42. What is the ratio of the Value added (% of GDP) in France in 2004 to that in 2010?
Provide a short and direct response. 1.14. What is the ratio of the Value added (% of GDP) in Greece in 2004 to that in 2010?
Your answer should be compact. 1.45. What is the ratio of the Value added (% of GDP) in Namibia in 2004 to that in 2010?
Offer a very short reply. 1.05. What is the ratio of the Value added (% of GDP) of Cuba in 2004 to that in 2011?
Your response must be concise. 1.42. What is the ratio of the Value added (% of GDP) in France in 2004 to that in 2011?
Your response must be concise. 1.1. What is the ratio of the Value added (% of GDP) of Greece in 2004 to that in 2011?
Provide a short and direct response. 1.41. What is the ratio of the Value added (% of GDP) in Namibia in 2004 to that in 2011?
Your response must be concise. 1.09. What is the ratio of the Value added (% of GDP) in Cuba in 2005 to that in 2006?
Provide a short and direct response. 1.25. What is the ratio of the Value added (% of GDP) in France in 2005 to that in 2006?
Provide a succinct answer. 1.1. What is the ratio of the Value added (% of GDP) of Greece in 2005 to that in 2006?
Your answer should be very brief. 1.32. What is the ratio of the Value added (% of GDP) in Namibia in 2005 to that in 2006?
Make the answer very short. 1.08. What is the ratio of the Value added (% of GDP) in Cuba in 2005 to that in 2007?
Provide a short and direct response. 1.13. What is the ratio of the Value added (% of GDP) of France in 2005 to that in 2007?
Provide a short and direct response. 1.04. What is the ratio of the Value added (% of GDP) of Greece in 2005 to that in 2007?
Your response must be concise. 1.39. What is the ratio of the Value added (% of GDP) of Namibia in 2005 to that in 2007?
Your answer should be compact. 1.23. What is the ratio of the Value added (% of GDP) of Cuba in 2005 to that in 2008?
Provide a short and direct response. 1.13. What is the ratio of the Value added (% of GDP) in France in 2005 to that in 2008?
Provide a succinct answer. 1.11. What is the ratio of the Value added (% of GDP) of Greece in 2005 to that in 2008?
Provide a short and direct response. 1.5. What is the ratio of the Value added (% of GDP) in Namibia in 2005 to that in 2008?
Provide a succinct answer. 1.38. What is the ratio of the Value added (% of GDP) in Cuba in 2005 to that in 2009?
Offer a terse response. 1.11. What is the ratio of the Value added (% of GDP) of France in 2005 to that in 2009?
Make the answer very short. 1.28. What is the ratio of the Value added (% of GDP) in Greece in 2005 to that in 2009?
Ensure brevity in your answer.  1.52. What is the ratio of the Value added (% of GDP) of Namibia in 2005 to that in 2009?
Keep it short and to the point. 1.26. What is the ratio of the Value added (% of GDP) in Cuba in 2005 to that in 2010?
Provide a succinct answer. 1.13. What is the ratio of the Value added (% of GDP) of France in 2005 to that in 2010?
Provide a short and direct response. 1.05. What is the ratio of the Value added (% of GDP) in Greece in 2005 to that in 2010?
Your response must be concise. 1.46. What is the ratio of the Value added (% of GDP) in Namibia in 2005 to that in 2010?
Your response must be concise. 1.22. What is the ratio of the Value added (% of GDP) of Cuba in 2005 to that in 2011?
Provide a short and direct response. 1.12. What is the ratio of the Value added (% of GDP) in France in 2005 to that in 2011?
Offer a terse response. 1.02. What is the ratio of the Value added (% of GDP) of Greece in 2005 to that in 2011?
Ensure brevity in your answer.  1.42. What is the ratio of the Value added (% of GDP) of Namibia in 2005 to that in 2011?
Your answer should be very brief. 1.27. What is the ratio of the Value added (% of GDP) of Cuba in 2006 to that in 2007?
Your answer should be very brief. 0.9. What is the ratio of the Value added (% of GDP) of France in 2006 to that in 2007?
Give a very brief answer. 0.94. What is the ratio of the Value added (% of GDP) of Greece in 2006 to that in 2007?
Provide a succinct answer. 1.05. What is the ratio of the Value added (% of GDP) in Namibia in 2006 to that in 2007?
Provide a short and direct response. 1.13. What is the ratio of the Value added (% of GDP) in Cuba in 2006 to that in 2008?
Your answer should be very brief. 0.9. What is the ratio of the Value added (% of GDP) of France in 2006 to that in 2008?
Provide a succinct answer. 1.01. What is the ratio of the Value added (% of GDP) in Greece in 2006 to that in 2008?
Make the answer very short. 1.14. What is the ratio of the Value added (% of GDP) of Namibia in 2006 to that in 2008?
Offer a terse response. 1.27. What is the ratio of the Value added (% of GDP) of Cuba in 2006 to that in 2009?
Your answer should be compact. 0.89. What is the ratio of the Value added (% of GDP) in France in 2006 to that in 2009?
Offer a very short reply. 1.16. What is the ratio of the Value added (% of GDP) of Greece in 2006 to that in 2009?
Provide a succinct answer. 1.15. What is the ratio of the Value added (% of GDP) of Namibia in 2006 to that in 2009?
Keep it short and to the point. 1.17. What is the ratio of the Value added (% of GDP) in Cuba in 2006 to that in 2010?
Your answer should be compact. 0.9. What is the ratio of the Value added (% of GDP) in France in 2006 to that in 2010?
Keep it short and to the point. 0.95. What is the ratio of the Value added (% of GDP) of Greece in 2006 to that in 2010?
Provide a short and direct response. 1.11. What is the ratio of the Value added (% of GDP) of Namibia in 2006 to that in 2010?
Keep it short and to the point. 1.13. What is the ratio of the Value added (% of GDP) in Cuba in 2006 to that in 2011?
Ensure brevity in your answer.  0.9. What is the ratio of the Value added (% of GDP) in France in 2006 to that in 2011?
Ensure brevity in your answer.  0.92. What is the ratio of the Value added (% of GDP) in Greece in 2006 to that in 2011?
Provide a succinct answer. 1.08. What is the ratio of the Value added (% of GDP) of Namibia in 2006 to that in 2011?
Make the answer very short. 1.18. What is the ratio of the Value added (% of GDP) of Cuba in 2007 to that in 2008?
Offer a very short reply. 1. What is the ratio of the Value added (% of GDP) in France in 2007 to that in 2008?
Provide a short and direct response. 1.07. What is the ratio of the Value added (% of GDP) in Greece in 2007 to that in 2008?
Your answer should be very brief. 1.08. What is the ratio of the Value added (% of GDP) of Namibia in 2007 to that in 2008?
Make the answer very short. 1.12. What is the ratio of the Value added (% of GDP) of France in 2007 to that in 2009?
Make the answer very short. 1.23. What is the ratio of the Value added (% of GDP) in Greece in 2007 to that in 2009?
Provide a succinct answer. 1.1. What is the ratio of the Value added (% of GDP) of Namibia in 2007 to that in 2009?
Provide a short and direct response. 1.03. What is the ratio of the Value added (% of GDP) in Cuba in 2007 to that in 2010?
Ensure brevity in your answer.  1. What is the ratio of the Value added (% of GDP) in France in 2007 to that in 2010?
Keep it short and to the point. 1.01. What is the ratio of the Value added (% of GDP) of Greece in 2007 to that in 2010?
Offer a terse response. 1.05. What is the ratio of the Value added (% of GDP) in Namibia in 2007 to that in 2010?
Offer a very short reply. 0.99. What is the ratio of the Value added (% of GDP) in Cuba in 2007 to that in 2011?
Keep it short and to the point. 0.99. What is the ratio of the Value added (% of GDP) of France in 2007 to that in 2011?
Your response must be concise. 0.98. What is the ratio of the Value added (% of GDP) of Greece in 2007 to that in 2011?
Provide a succinct answer. 1.03. What is the ratio of the Value added (% of GDP) of Namibia in 2007 to that in 2011?
Offer a terse response. 1.04. What is the ratio of the Value added (% of GDP) in Cuba in 2008 to that in 2009?
Give a very brief answer. 0.98. What is the ratio of the Value added (% of GDP) of France in 2008 to that in 2009?
Your answer should be compact. 1.15. What is the ratio of the Value added (% of GDP) in Greece in 2008 to that in 2009?
Give a very brief answer. 1.01. What is the ratio of the Value added (% of GDP) of Namibia in 2008 to that in 2009?
Offer a very short reply. 0.92. What is the ratio of the Value added (% of GDP) in Cuba in 2008 to that in 2010?
Ensure brevity in your answer.  0.99. What is the ratio of the Value added (% of GDP) in France in 2008 to that in 2010?
Your answer should be very brief. 0.95. What is the ratio of the Value added (% of GDP) of Namibia in 2008 to that in 2010?
Provide a short and direct response. 0.89. What is the ratio of the Value added (% of GDP) of France in 2008 to that in 2011?
Offer a very short reply. 0.92. What is the ratio of the Value added (% of GDP) of Greece in 2008 to that in 2011?
Your response must be concise. 0.95. What is the ratio of the Value added (% of GDP) of Namibia in 2008 to that in 2011?
Provide a succinct answer. 0.92. What is the ratio of the Value added (% of GDP) of Cuba in 2009 to that in 2010?
Provide a succinct answer. 1.01. What is the ratio of the Value added (% of GDP) in France in 2009 to that in 2010?
Your answer should be very brief. 0.82. What is the ratio of the Value added (% of GDP) in Greece in 2009 to that in 2010?
Your answer should be very brief. 0.96. What is the ratio of the Value added (% of GDP) of Cuba in 2009 to that in 2011?
Provide a succinct answer. 1.01. What is the ratio of the Value added (% of GDP) in France in 2009 to that in 2011?
Provide a short and direct response. 0.8. What is the ratio of the Value added (% of GDP) in Greece in 2009 to that in 2011?
Give a very brief answer. 0.93. What is the ratio of the Value added (% of GDP) in Namibia in 2009 to that in 2011?
Offer a terse response. 1.01. What is the ratio of the Value added (% of GDP) in France in 2010 to that in 2011?
Provide a succinct answer. 0.97. What is the ratio of the Value added (% of GDP) in Greece in 2010 to that in 2011?
Make the answer very short. 0.97. What is the ratio of the Value added (% of GDP) of Namibia in 2010 to that in 2011?
Make the answer very short. 1.04. What is the difference between the highest and the second highest Value added (% of GDP) of Cuba?
Your response must be concise. 1.47. What is the difference between the highest and the second highest Value added (% of GDP) in France?
Your response must be concise. 0.16. What is the difference between the highest and the second highest Value added (% of GDP) in Greece?
Offer a terse response. 0.03. What is the difference between the highest and the second highest Value added (% of GDP) of Namibia?
Give a very brief answer. 0.86. What is the difference between the highest and the lowest Value added (% of GDP) in Cuba?
Offer a terse response. 2.61. What is the difference between the highest and the lowest Value added (% of GDP) in France?
Your response must be concise. 0.56. What is the difference between the highest and the lowest Value added (% of GDP) of Greece?
Keep it short and to the point. 1.64. What is the difference between the highest and the lowest Value added (% of GDP) in Namibia?
Your answer should be very brief. 3.09. 